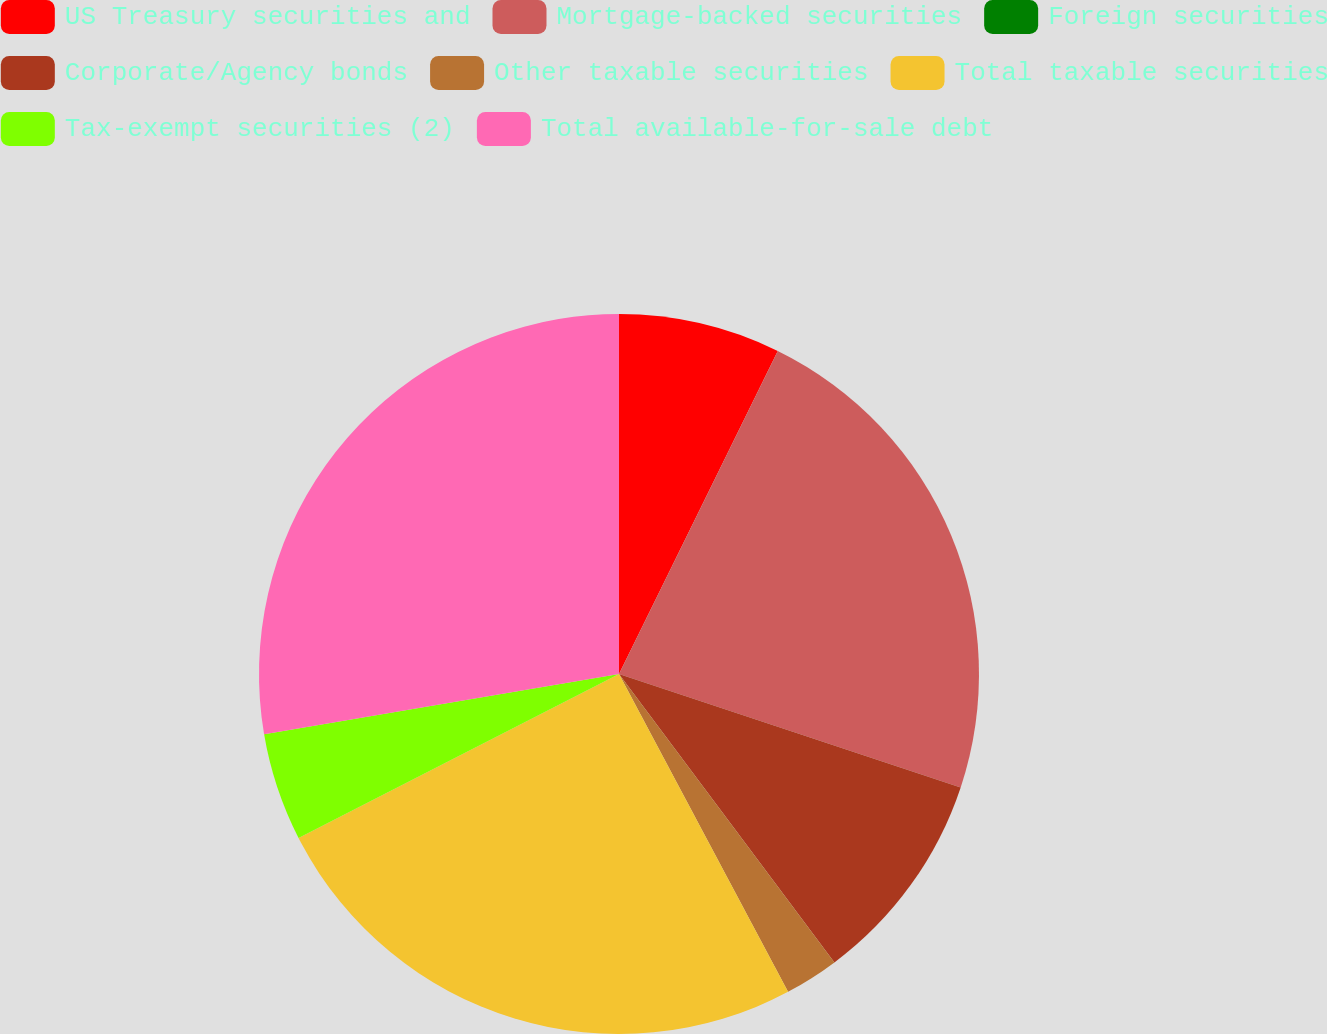Convert chart to OTSL. <chart><loc_0><loc_0><loc_500><loc_500><pie_chart><fcel>US Treasury securities and<fcel>Mortgage-backed securities<fcel>Foreign securities<fcel>Corporate/Agency bonds<fcel>Other taxable securities<fcel>Total taxable securities<fcel>Tax-exempt securities (2)<fcel>Total available-for-sale debt<nl><fcel>7.27%<fcel>22.83%<fcel>0.0%<fcel>9.69%<fcel>2.43%<fcel>25.25%<fcel>4.85%<fcel>27.68%<nl></chart> 